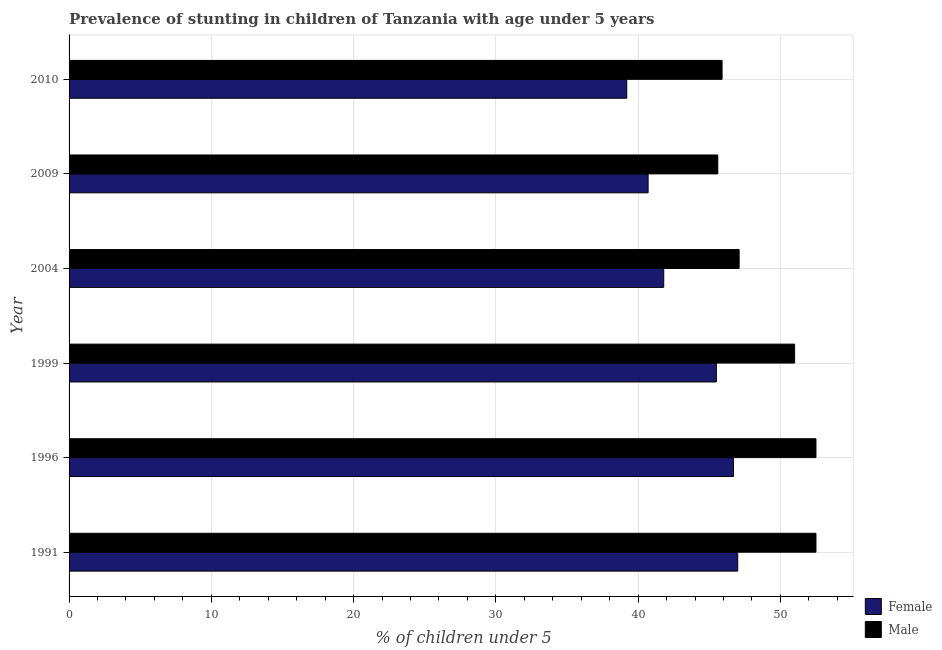How many different coloured bars are there?
Provide a succinct answer. 2. How many groups of bars are there?
Make the answer very short. 6. Are the number of bars per tick equal to the number of legend labels?
Provide a succinct answer. Yes. What is the label of the 5th group of bars from the top?
Make the answer very short. 1996. In how many cases, is the number of bars for a given year not equal to the number of legend labels?
Give a very brief answer. 0. What is the percentage of stunted male children in 2010?
Offer a very short reply. 45.9. Across all years, what is the maximum percentage of stunted female children?
Keep it short and to the point. 47. Across all years, what is the minimum percentage of stunted female children?
Provide a succinct answer. 39.2. In which year was the percentage of stunted female children maximum?
Provide a succinct answer. 1991. In which year was the percentage of stunted female children minimum?
Your answer should be very brief. 2010. What is the total percentage of stunted male children in the graph?
Keep it short and to the point. 294.6. What is the average percentage of stunted female children per year?
Provide a succinct answer. 43.48. What is the ratio of the percentage of stunted male children in 1996 to that in 2004?
Provide a succinct answer. 1.11. Is the percentage of stunted female children in 1991 less than that in 2010?
Your answer should be compact. No. Is the difference between the percentage of stunted female children in 1999 and 2009 greater than the difference between the percentage of stunted male children in 1999 and 2009?
Provide a short and direct response. No. What is the difference between the highest and the second highest percentage of stunted male children?
Your response must be concise. 0. What is the difference between the highest and the lowest percentage of stunted female children?
Your response must be concise. 7.8. Is the sum of the percentage of stunted male children in 2009 and 2010 greater than the maximum percentage of stunted female children across all years?
Offer a very short reply. Yes. What does the 1st bar from the top in 2010 represents?
Your answer should be compact. Male. What does the 2nd bar from the bottom in 1991 represents?
Keep it short and to the point. Male. How many years are there in the graph?
Offer a very short reply. 6. Does the graph contain any zero values?
Offer a terse response. No. Where does the legend appear in the graph?
Your response must be concise. Bottom right. How many legend labels are there?
Make the answer very short. 2. What is the title of the graph?
Make the answer very short. Prevalence of stunting in children of Tanzania with age under 5 years. Does "Lowest 20% of population" appear as one of the legend labels in the graph?
Make the answer very short. No. What is the label or title of the X-axis?
Your answer should be compact.  % of children under 5. What is the label or title of the Y-axis?
Provide a succinct answer. Year. What is the  % of children under 5 of Male in 1991?
Your response must be concise. 52.5. What is the  % of children under 5 in Female in 1996?
Your answer should be compact. 46.7. What is the  % of children under 5 of Male in 1996?
Give a very brief answer. 52.5. What is the  % of children under 5 of Female in 1999?
Your answer should be very brief. 45.5. What is the  % of children under 5 of Female in 2004?
Provide a succinct answer. 41.8. What is the  % of children under 5 in Male in 2004?
Offer a terse response. 47.1. What is the  % of children under 5 of Female in 2009?
Offer a very short reply. 40.7. What is the  % of children under 5 of Male in 2009?
Offer a terse response. 45.6. What is the  % of children under 5 of Female in 2010?
Provide a short and direct response. 39.2. What is the  % of children under 5 of Male in 2010?
Your response must be concise. 45.9. Across all years, what is the maximum  % of children under 5 in Female?
Your response must be concise. 47. Across all years, what is the maximum  % of children under 5 of Male?
Keep it short and to the point. 52.5. Across all years, what is the minimum  % of children under 5 of Female?
Provide a succinct answer. 39.2. Across all years, what is the minimum  % of children under 5 in Male?
Your response must be concise. 45.6. What is the total  % of children under 5 of Female in the graph?
Keep it short and to the point. 260.9. What is the total  % of children under 5 of Male in the graph?
Make the answer very short. 294.6. What is the difference between the  % of children under 5 in Female in 1991 and that in 1996?
Offer a terse response. 0.3. What is the difference between the  % of children under 5 in Female in 1991 and that in 1999?
Give a very brief answer. 1.5. What is the difference between the  % of children under 5 in Female in 1991 and that in 2004?
Your answer should be compact. 5.2. What is the difference between the  % of children under 5 of Male in 1991 and that in 2009?
Offer a terse response. 6.9. What is the difference between the  % of children under 5 of Male in 1991 and that in 2010?
Ensure brevity in your answer.  6.6. What is the difference between the  % of children under 5 in Female in 1996 and that in 1999?
Provide a succinct answer. 1.2. What is the difference between the  % of children under 5 of Female in 1996 and that in 2004?
Give a very brief answer. 4.9. What is the difference between the  % of children under 5 of Female in 1996 and that in 2009?
Provide a short and direct response. 6. What is the difference between the  % of children under 5 in Male in 1996 and that in 2009?
Provide a short and direct response. 6.9. What is the difference between the  % of children under 5 of Female in 1996 and that in 2010?
Ensure brevity in your answer.  7.5. What is the difference between the  % of children under 5 in Female in 1999 and that in 2009?
Offer a terse response. 4.8. What is the difference between the  % of children under 5 of Male in 1999 and that in 2009?
Make the answer very short. 5.4. What is the difference between the  % of children under 5 in Female in 1999 and that in 2010?
Keep it short and to the point. 6.3. What is the difference between the  % of children under 5 in Female in 2004 and that in 2009?
Make the answer very short. 1.1. What is the difference between the  % of children under 5 of Female in 2004 and that in 2010?
Keep it short and to the point. 2.6. What is the difference between the  % of children under 5 of Male in 2004 and that in 2010?
Your response must be concise. 1.2. What is the difference between the  % of children under 5 of Female in 1991 and the  % of children under 5 of Male in 1996?
Give a very brief answer. -5.5. What is the difference between the  % of children under 5 of Female in 1991 and the  % of children under 5 of Male in 2004?
Give a very brief answer. -0.1. What is the difference between the  % of children under 5 in Female in 1991 and the  % of children under 5 in Male in 2009?
Your answer should be compact. 1.4. What is the difference between the  % of children under 5 of Female in 1996 and the  % of children under 5 of Male in 1999?
Provide a short and direct response. -4.3. What is the difference between the  % of children under 5 of Female in 1996 and the  % of children under 5 of Male in 2010?
Keep it short and to the point. 0.8. What is the difference between the  % of children under 5 of Female in 1999 and the  % of children under 5 of Male in 2004?
Ensure brevity in your answer.  -1.6. What is the difference between the  % of children under 5 in Female in 1999 and the  % of children under 5 in Male in 2010?
Offer a very short reply. -0.4. What is the difference between the  % of children under 5 in Female in 2004 and the  % of children under 5 in Male in 2009?
Your answer should be very brief. -3.8. What is the difference between the  % of children under 5 in Female in 2004 and the  % of children under 5 in Male in 2010?
Provide a short and direct response. -4.1. What is the average  % of children under 5 of Female per year?
Offer a terse response. 43.48. What is the average  % of children under 5 of Male per year?
Provide a short and direct response. 49.1. In the year 1999, what is the difference between the  % of children under 5 in Female and  % of children under 5 in Male?
Your answer should be compact. -5.5. In the year 2010, what is the difference between the  % of children under 5 of Female and  % of children under 5 of Male?
Make the answer very short. -6.7. What is the ratio of the  % of children under 5 in Female in 1991 to that in 1996?
Offer a terse response. 1.01. What is the ratio of the  % of children under 5 in Male in 1991 to that in 1996?
Keep it short and to the point. 1. What is the ratio of the  % of children under 5 in Female in 1991 to that in 1999?
Give a very brief answer. 1.03. What is the ratio of the  % of children under 5 of Male in 1991 to that in 1999?
Ensure brevity in your answer.  1.03. What is the ratio of the  % of children under 5 of Female in 1991 to that in 2004?
Your response must be concise. 1.12. What is the ratio of the  % of children under 5 of Male in 1991 to that in 2004?
Your response must be concise. 1.11. What is the ratio of the  % of children under 5 in Female in 1991 to that in 2009?
Keep it short and to the point. 1.15. What is the ratio of the  % of children under 5 of Male in 1991 to that in 2009?
Your answer should be compact. 1.15. What is the ratio of the  % of children under 5 of Female in 1991 to that in 2010?
Your answer should be very brief. 1.2. What is the ratio of the  % of children under 5 in Male in 1991 to that in 2010?
Your answer should be compact. 1.14. What is the ratio of the  % of children under 5 of Female in 1996 to that in 1999?
Your answer should be compact. 1.03. What is the ratio of the  % of children under 5 of Male in 1996 to that in 1999?
Offer a very short reply. 1.03. What is the ratio of the  % of children under 5 of Female in 1996 to that in 2004?
Offer a terse response. 1.12. What is the ratio of the  % of children under 5 in Male in 1996 to that in 2004?
Keep it short and to the point. 1.11. What is the ratio of the  % of children under 5 of Female in 1996 to that in 2009?
Keep it short and to the point. 1.15. What is the ratio of the  % of children under 5 of Male in 1996 to that in 2009?
Your answer should be compact. 1.15. What is the ratio of the  % of children under 5 in Female in 1996 to that in 2010?
Provide a short and direct response. 1.19. What is the ratio of the  % of children under 5 of Male in 1996 to that in 2010?
Your answer should be compact. 1.14. What is the ratio of the  % of children under 5 in Female in 1999 to that in 2004?
Ensure brevity in your answer.  1.09. What is the ratio of the  % of children under 5 of Male in 1999 to that in 2004?
Make the answer very short. 1.08. What is the ratio of the  % of children under 5 in Female in 1999 to that in 2009?
Keep it short and to the point. 1.12. What is the ratio of the  % of children under 5 in Male in 1999 to that in 2009?
Give a very brief answer. 1.12. What is the ratio of the  % of children under 5 in Female in 1999 to that in 2010?
Your answer should be compact. 1.16. What is the ratio of the  % of children under 5 in Male in 2004 to that in 2009?
Offer a terse response. 1.03. What is the ratio of the  % of children under 5 of Female in 2004 to that in 2010?
Keep it short and to the point. 1.07. What is the ratio of the  % of children under 5 in Male in 2004 to that in 2010?
Offer a very short reply. 1.03. What is the ratio of the  % of children under 5 in Female in 2009 to that in 2010?
Make the answer very short. 1.04. What is the ratio of the  % of children under 5 in Male in 2009 to that in 2010?
Offer a very short reply. 0.99. What is the difference between the highest and the lowest  % of children under 5 of Female?
Make the answer very short. 7.8. 